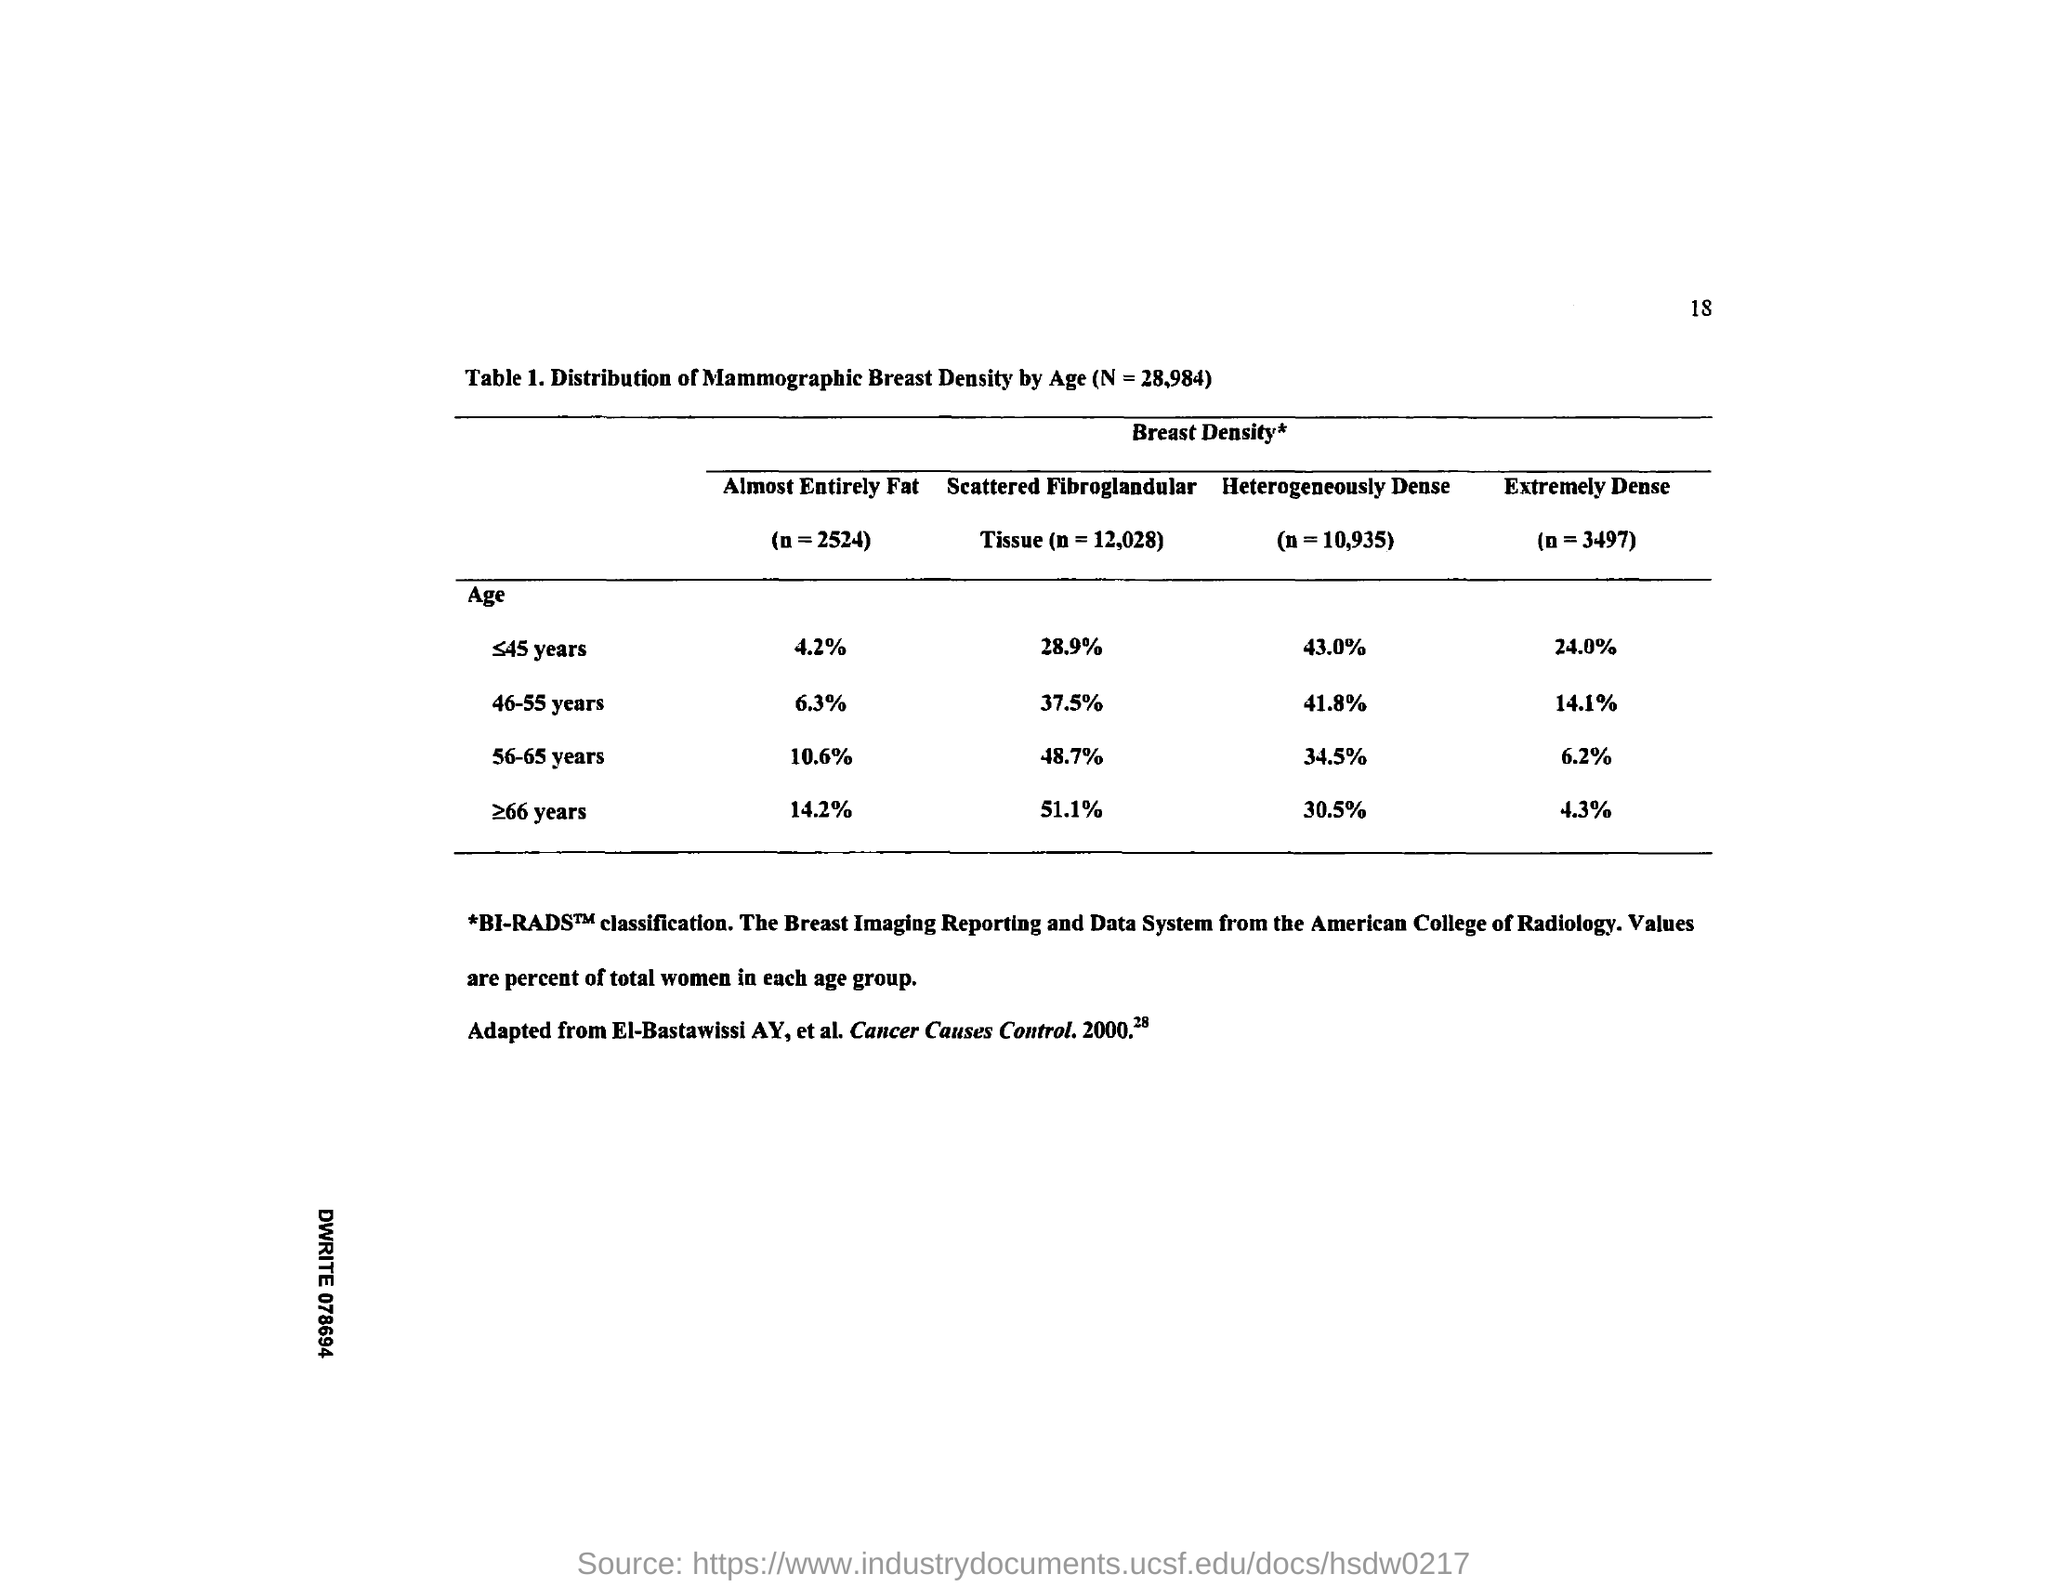Point out several critical features in this image. The value of almost entirely fat for the age range of 56-65 years is 10.6%. In individuals aged 56-65 years, the density of bone varies, with a heterogeneously dense pattern making up 34.5% of the population in this age range. The percentage of scattered fibroglandular tissue for individuals aged 46 to 55 years is 37.5%. According to the data, the value of heterogeneously dense is highest for the age group of 46-55 years, at 41.8%. The value of almost entirely fat for individuals aged 46-55 years is approximately 6.3%. 